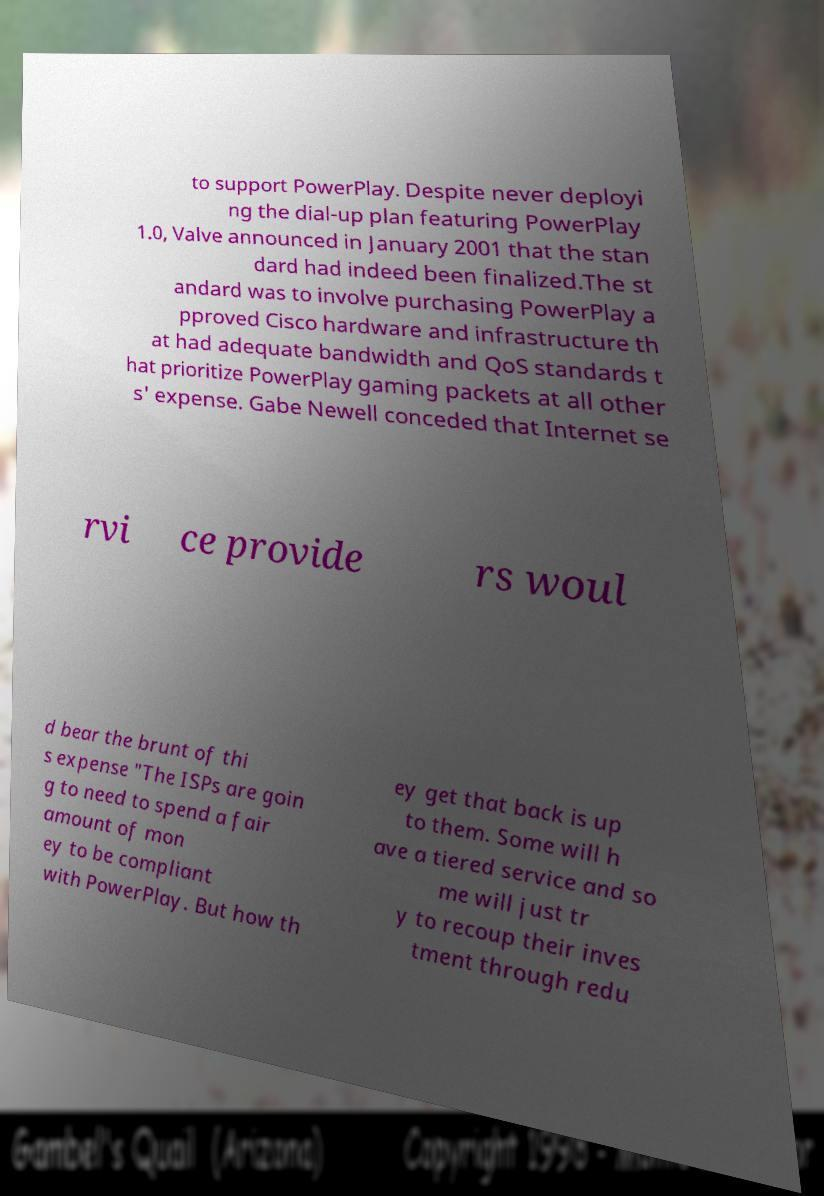Could you assist in decoding the text presented in this image and type it out clearly? to support PowerPlay. Despite never deployi ng the dial-up plan featuring PowerPlay 1.0, Valve announced in January 2001 that the stan dard had indeed been finalized.The st andard was to involve purchasing PowerPlay a pproved Cisco hardware and infrastructure th at had adequate bandwidth and QoS standards t hat prioritize PowerPlay gaming packets at all other s' expense. Gabe Newell conceded that Internet se rvi ce provide rs woul d bear the brunt of thi s expense "The ISPs are goin g to need to spend a fair amount of mon ey to be compliant with PowerPlay. But how th ey get that back is up to them. Some will h ave a tiered service and so me will just tr y to recoup their inves tment through redu 